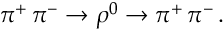Convert formula to latex. <formula><loc_0><loc_0><loc_500><loc_500>\pi ^ { + } \, \pi ^ { - } \rightarrow \rho ^ { 0 } \rightarrow \pi ^ { + } \, \pi ^ { - } \, .</formula> 